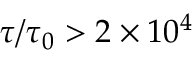Convert formula to latex. <formula><loc_0><loc_0><loc_500><loc_500>\tau / \tau _ { 0 } > 2 \times 1 0 ^ { 4 }</formula> 